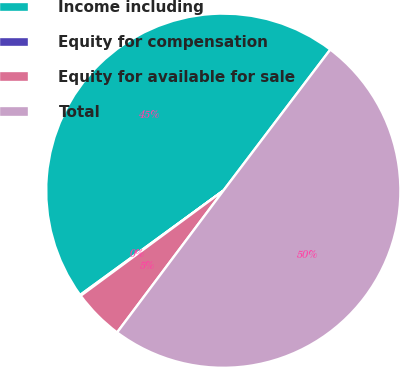Convert chart. <chart><loc_0><loc_0><loc_500><loc_500><pie_chart><fcel>Income including<fcel>Equity for compensation<fcel>Equity for available for sale<fcel>Total<nl><fcel>45.34%<fcel>0.09%<fcel>4.66%<fcel>49.91%<nl></chart> 